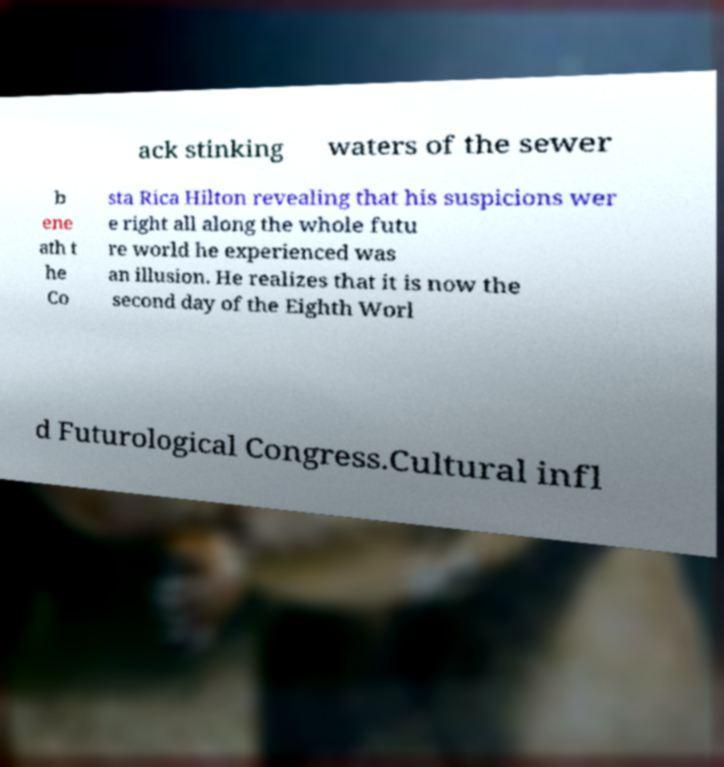Please read and relay the text visible in this image. What does it say? ack stinking waters of the sewer b ene ath t he Co sta Rica Hilton revealing that his suspicions wer e right all along the whole futu re world he experienced was an illusion. He realizes that it is now the second day of the Eighth Worl d Futurological Congress.Cultural infl 